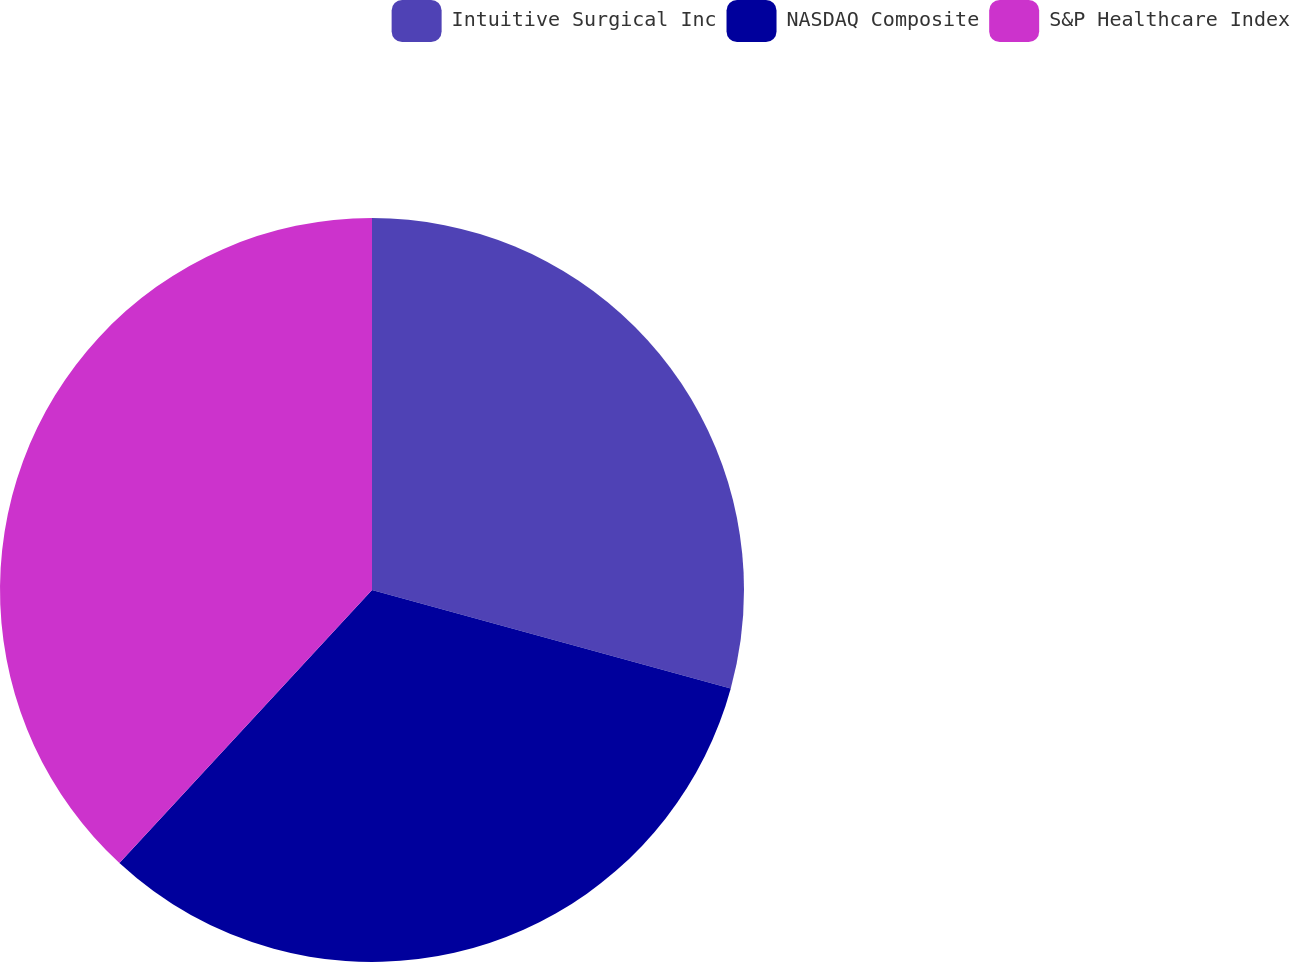Convert chart to OTSL. <chart><loc_0><loc_0><loc_500><loc_500><pie_chart><fcel>Intuitive Surgical Inc<fcel>NASDAQ Composite<fcel>S&P Healthcare Index<nl><fcel>29.26%<fcel>32.62%<fcel>38.12%<nl></chart> 